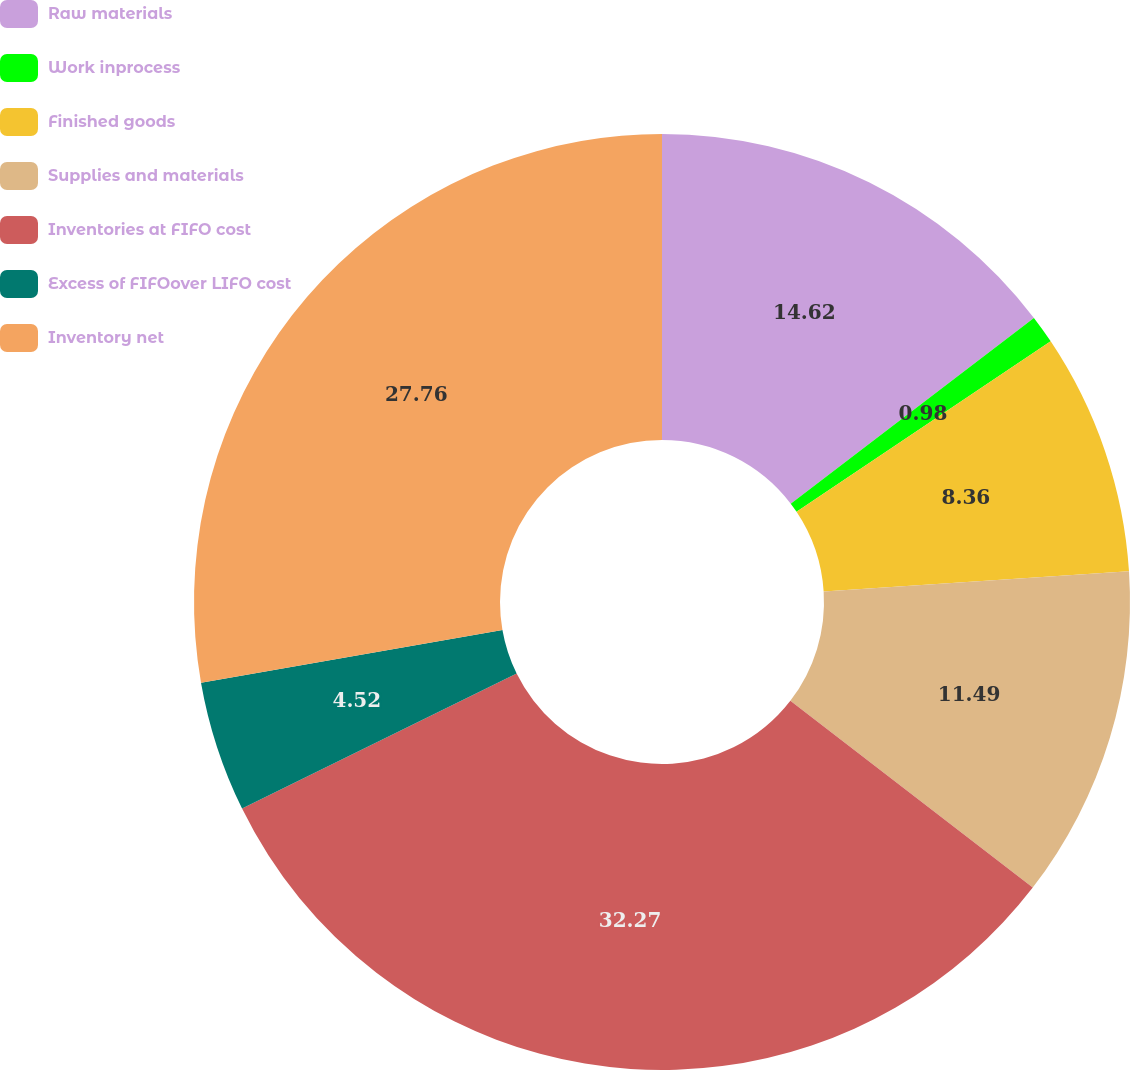Convert chart to OTSL. <chart><loc_0><loc_0><loc_500><loc_500><pie_chart><fcel>Raw materials<fcel>Work inprocess<fcel>Finished goods<fcel>Supplies and materials<fcel>Inventories at FIFO cost<fcel>Excess of FIFOover LIFO cost<fcel>Inventory net<nl><fcel>14.62%<fcel>0.98%<fcel>8.36%<fcel>11.49%<fcel>32.28%<fcel>4.52%<fcel>27.76%<nl></chart> 